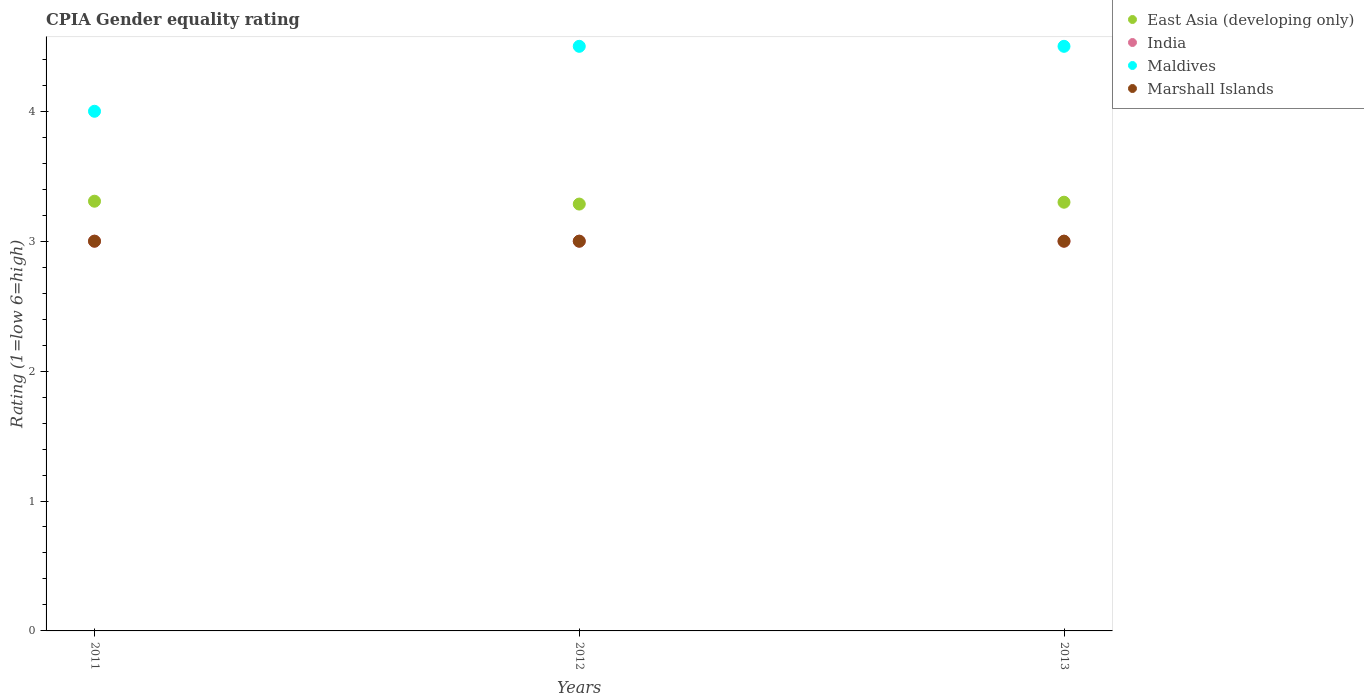What is the CPIA rating in India in 2011?
Your answer should be compact. 3. Across all years, what is the maximum CPIA rating in Maldives?
Your response must be concise. 4.5. In which year was the CPIA rating in India minimum?
Your answer should be very brief. 2011. What is the difference between the CPIA rating in Maldives in 2011 and that in 2012?
Give a very brief answer. -0.5. What is the average CPIA rating in East Asia (developing only) per year?
Ensure brevity in your answer.  3.3. In the year 2011, what is the difference between the CPIA rating in India and CPIA rating in Maldives?
Your answer should be very brief. -1. In how many years, is the CPIA rating in East Asia (developing only) greater than 1.8?
Give a very brief answer. 3. What is the ratio of the CPIA rating in Maldives in 2011 to that in 2013?
Give a very brief answer. 0.89. Is the CPIA rating in India in 2012 less than that in 2013?
Your answer should be very brief. No. Is the difference between the CPIA rating in India in 2011 and 2013 greater than the difference between the CPIA rating in Maldives in 2011 and 2013?
Make the answer very short. Yes. What is the difference between the highest and the lowest CPIA rating in India?
Offer a terse response. 0. Is it the case that in every year, the sum of the CPIA rating in Maldives and CPIA rating in India  is greater than the sum of CPIA rating in East Asia (developing only) and CPIA rating in Marshall Islands?
Your answer should be compact. No. Does the CPIA rating in India monotonically increase over the years?
Make the answer very short. No. How many years are there in the graph?
Offer a terse response. 3. Are the values on the major ticks of Y-axis written in scientific E-notation?
Provide a succinct answer. No. Does the graph contain grids?
Offer a very short reply. No. Where does the legend appear in the graph?
Offer a very short reply. Top right. How are the legend labels stacked?
Provide a short and direct response. Vertical. What is the title of the graph?
Provide a short and direct response. CPIA Gender equality rating. What is the label or title of the X-axis?
Give a very brief answer. Years. What is the label or title of the Y-axis?
Offer a terse response. Rating (1=low 6=high). What is the Rating (1=low 6=high) in East Asia (developing only) in 2011?
Your answer should be very brief. 3.31. What is the Rating (1=low 6=high) of Marshall Islands in 2011?
Make the answer very short. 3. What is the Rating (1=low 6=high) of East Asia (developing only) in 2012?
Your answer should be compact. 3.29. What is the Rating (1=low 6=high) of India in 2012?
Your response must be concise. 3. What is the Rating (1=low 6=high) in East Asia (developing only) in 2013?
Your answer should be compact. 3.3. What is the Rating (1=low 6=high) of India in 2013?
Your answer should be very brief. 3. What is the Rating (1=low 6=high) of Maldives in 2013?
Your answer should be compact. 4.5. What is the Rating (1=low 6=high) of Marshall Islands in 2013?
Provide a short and direct response. 3. Across all years, what is the maximum Rating (1=low 6=high) of East Asia (developing only)?
Make the answer very short. 3.31. Across all years, what is the maximum Rating (1=low 6=high) in Marshall Islands?
Offer a terse response. 3. Across all years, what is the minimum Rating (1=low 6=high) of East Asia (developing only)?
Offer a terse response. 3.29. What is the total Rating (1=low 6=high) of East Asia (developing only) in the graph?
Make the answer very short. 9.89. What is the total Rating (1=low 6=high) of Maldives in the graph?
Give a very brief answer. 13. What is the total Rating (1=low 6=high) in Marshall Islands in the graph?
Your response must be concise. 9. What is the difference between the Rating (1=low 6=high) in East Asia (developing only) in 2011 and that in 2012?
Offer a terse response. 0.02. What is the difference between the Rating (1=low 6=high) in Maldives in 2011 and that in 2012?
Provide a short and direct response. -0.5. What is the difference between the Rating (1=low 6=high) in Marshall Islands in 2011 and that in 2012?
Your response must be concise. 0. What is the difference between the Rating (1=low 6=high) of East Asia (developing only) in 2011 and that in 2013?
Your answer should be compact. 0.01. What is the difference between the Rating (1=low 6=high) of Marshall Islands in 2011 and that in 2013?
Keep it short and to the point. 0. What is the difference between the Rating (1=low 6=high) of East Asia (developing only) in 2012 and that in 2013?
Your answer should be compact. -0.01. What is the difference between the Rating (1=low 6=high) of Marshall Islands in 2012 and that in 2013?
Offer a terse response. 0. What is the difference between the Rating (1=low 6=high) in East Asia (developing only) in 2011 and the Rating (1=low 6=high) in India in 2012?
Your answer should be compact. 0.31. What is the difference between the Rating (1=low 6=high) of East Asia (developing only) in 2011 and the Rating (1=low 6=high) of Maldives in 2012?
Ensure brevity in your answer.  -1.19. What is the difference between the Rating (1=low 6=high) of East Asia (developing only) in 2011 and the Rating (1=low 6=high) of Marshall Islands in 2012?
Give a very brief answer. 0.31. What is the difference between the Rating (1=low 6=high) of Maldives in 2011 and the Rating (1=low 6=high) of Marshall Islands in 2012?
Your response must be concise. 1. What is the difference between the Rating (1=low 6=high) in East Asia (developing only) in 2011 and the Rating (1=low 6=high) in India in 2013?
Offer a terse response. 0.31. What is the difference between the Rating (1=low 6=high) of East Asia (developing only) in 2011 and the Rating (1=low 6=high) of Maldives in 2013?
Provide a short and direct response. -1.19. What is the difference between the Rating (1=low 6=high) of East Asia (developing only) in 2011 and the Rating (1=low 6=high) of Marshall Islands in 2013?
Provide a short and direct response. 0.31. What is the difference between the Rating (1=low 6=high) of India in 2011 and the Rating (1=low 6=high) of Maldives in 2013?
Provide a short and direct response. -1.5. What is the difference between the Rating (1=low 6=high) of India in 2011 and the Rating (1=low 6=high) of Marshall Islands in 2013?
Keep it short and to the point. 0. What is the difference between the Rating (1=low 6=high) of Maldives in 2011 and the Rating (1=low 6=high) of Marshall Islands in 2013?
Give a very brief answer. 1. What is the difference between the Rating (1=low 6=high) of East Asia (developing only) in 2012 and the Rating (1=low 6=high) of India in 2013?
Give a very brief answer. 0.29. What is the difference between the Rating (1=low 6=high) in East Asia (developing only) in 2012 and the Rating (1=low 6=high) in Maldives in 2013?
Make the answer very short. -1.21. What is the difference between the Rating (1=low 6=high) of East Asia (developing only) in 2012 and the Rating (1=low 6=high) of Marshall Islands in 2013?
Provide a short and direct response. 0.29. What is the difference between the Rating (1=low 6=high) in Maldives in 2012 and the Rating (1=low 6=high) in Marshall Islands in 2013?
Keep it short and to the point. 1.5. What is the average Rating (1=low 6=high) in East Asia (developing only) per year?
Your answer should be very brief. 3.3. What is the average Rating (1=low 6=high) in Maldives per year?
Your answer should be very brief. 4.33. In the year 2011, what is the difference between the Rating (1=low 6=high) in East Asia (developing only) and Rating (1=low 6=high) in India?
Offer a terse response. 0.31. In the year 2011, what is the difference between the Rating (1=low 6=high) of East Asia (developing only) and Rating (1=low 6=high) of Maldives?
Offer a very short reply. -0.69. In the year 2011, what is the difference between the Rating (1=low 6=high) in East Asia (developing only) and Rating (1=low 6=high) in Marshall Islands?
Keep it short and to the point. 0.31. In the year 2011, what is the difference between the Rating (1=low 6=high) of India and Rating (1=low 6=high) of Maldives?
Provide a short and direct response. -1. In the year 2011, what is the difference between the Rating (1=low 6=high) of India and Rating (1=low 6=high) of Marshall Islands?
Ensure brevity in your answer.  0. In the year 2011, what is the difference between the Rating (1=low 6=high) in Maldives and Rating (1=low 6=high) in Marshall Islands?
Your answer should be compact. 1. In the year 2012, what is the difference between the Rating (1=low 6=high) of East Asia (developing only) and Rating (1=low 6=high) of India?
Your response must be concise. 0.29. In the year 2012, what is the difference between the Rating (1=low 6=high) in East Asia (developing only) and Rating (1=low 6=high) in Maldives?
Provide a short and direct response. -1.21. In the year 2012, what is the difference between the Rating (1=low 6=high) in East Asia (developing only) and Rating (1=low 6=high) in Marshall Islands?
Ensure brevity in your answer.  0.29. In the year 2012, what is the difference between the Rating (1=low 6=high) in Maldives and Rating (1=low 6=high) in Marshall Islands?
Provide a short and direct response. 1.5. In the year 2013, what is the difference between the Rating (1=low 6=high) in East Asia (developing only) and Rating (1=low 6=high) in India?
Provide a succinct answer. 0.3. In the year 2013, what is the difference between the Rating (1=low 6=high) in East Asia (developing only) and Rating (1=low 6=high) in Marshall Islands?
Keep it short and to the point. 0.3. What is the ratio of the Rating (1=low 6=high) in East Asia (developing only) in 2011 to that in 2012?
Provide a succinct answer. 1.01. What is the ratio of the Rating (1=low 6=high) in India in 2011 to that in 2012?
Give a very brief answer. 1. What is the ratio of the Rating (1=low 6=high) in Marshall Islands in 2011 to that in 2012?
Ensure brevity in your answer.  1. What is the ratio of the Rating (1=low 6=high) of Maldives in 2011 to that in 2013?
Provide a short and direct response. 0.89. What is the ratio of the Rating (1=low 6=high) in Marshall Islands in 2011 to that in 2013?
Your response must be concise. 1. What is the ratio of the Rating (1=low 6=high) of India in 2012 to that in 2013?
Offer a terse response. 1. What is the ratio of the Rating (1=low 6=high) of Marshall Islands in 2012 to that in 2013?
Provide a succinct answer. 1. What is the difference between the highest and the second highest Rating (1=low 6=high) in East Asia (developing only)?
Ensure brevity in your answer.  0.01. What is the difference between the highest and the second highest Rating (1=low 6=high) in Maldives?
Keep it short and to the point. 0. What is the difference between the highest and the lowest Rating (1=low 6=high) in East Asia (developing only)?
Your response must be concise. 0.02. What is the difference between the highest and the lowest Rating (1=low 6=high) in Maldives?
Make the answer very short. 0.5. 